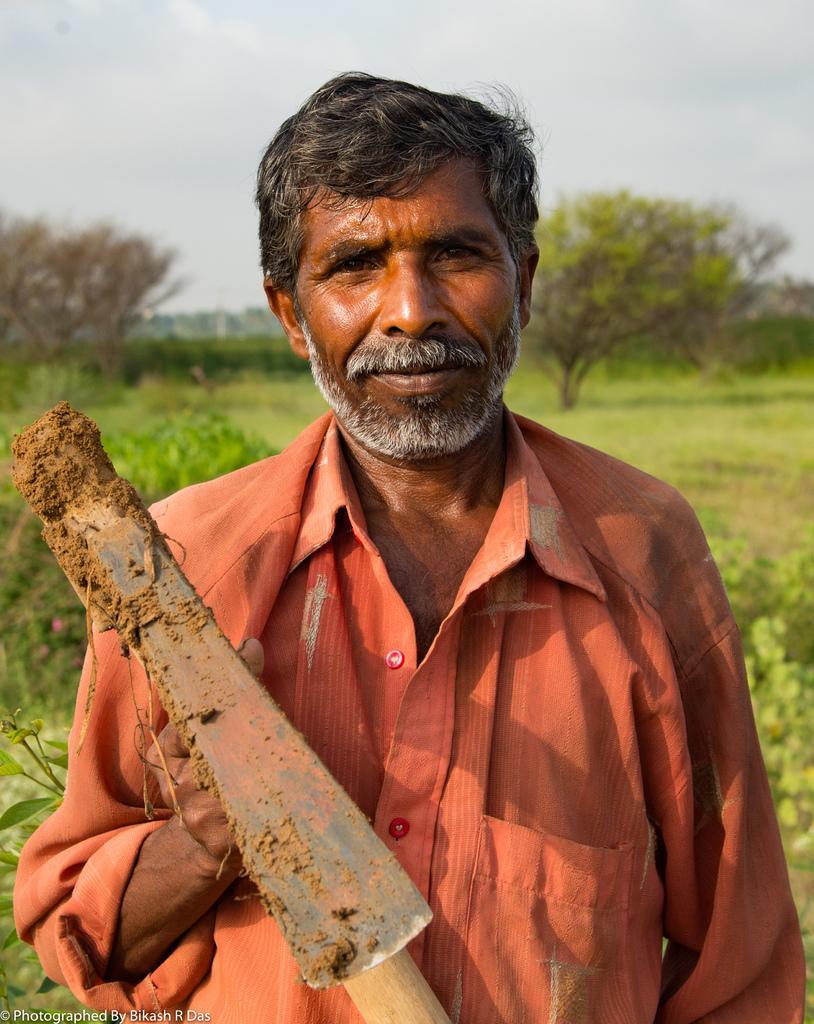Describe this image in one or two sentences. In the center of the image we can see a man standing and holding a pickaxe. In the background there are trees, plants, grass and sky. 